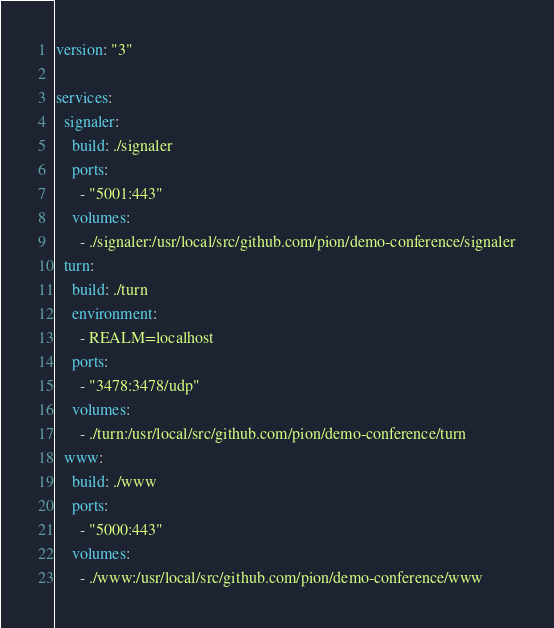Convert code to text. <code><loc_0><loc_0><loc_500><loc_500><_YAML_>version: "3"

services:
  signaler:
    build: ./signaler
    ports:
      - "5001:443"
    volumes:
      - ./signaler:/usr/local/src/github.com/pion/demo-conference/signaler
  turn:
    build: ./turn
    environment:
      - REALM=localhost
    ports:
      - "3478:3478/udp"
    volumes:
      - ./turn:/usr/local/src/github.com/pion/demo-conference/turn
  www:
    build: ./www
    ports:
      - "5000:443"
    volumes:
      - ./www:/usr/local/src/github.com/pion/demo-conference/www
</code> 